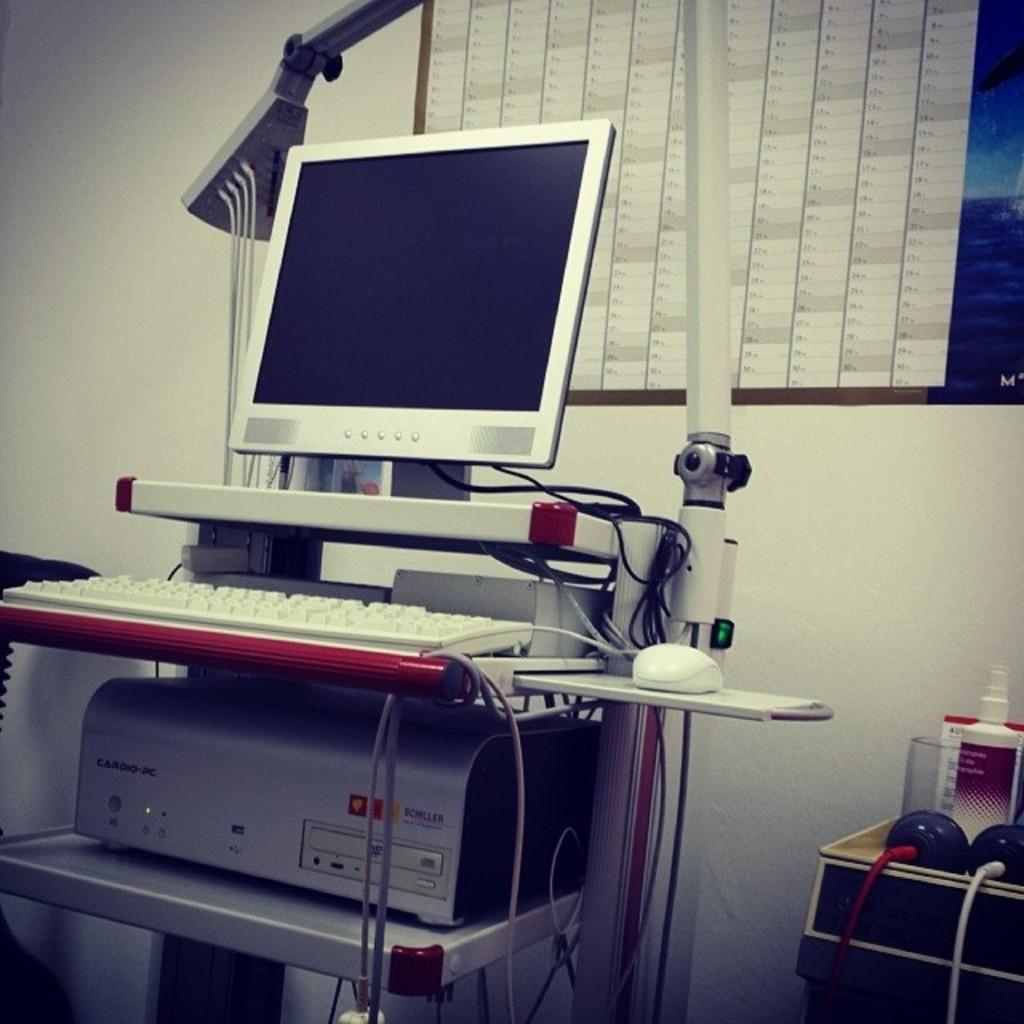What is the main electronic device visible in the image? There is a monitor in the image. Are there any other electronic devices present besides the monitor? Yes, there are other electronic devices in the image. What can be seen in the background of the image? There is a window and a wall in the background of the image. What is located on the right side of the image? There are objects on the right side of the image. What type of jewel is being kicked around in the image? There is no jewel or any kicking activity present in the image. 